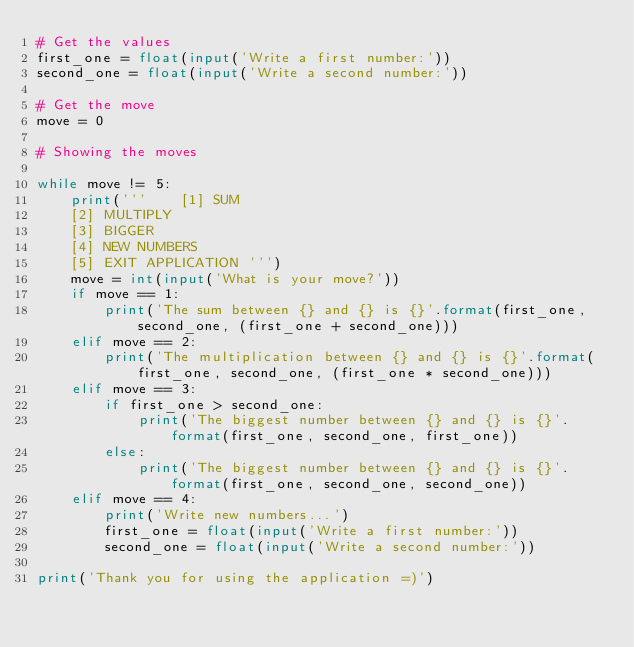Convert code to text. <code><loc_0><loc_0><loc_500><loc_500><_Python_># Get the values
first_one = float(input('Write a first number:'))
second_one = float(input('Write a second number:'))

# Get the move
move = 0

# Showing the moves

while move != 5:
    print('''    [1] SUM
    [2] MULTIPLY
    [3] BIGGER
    [4] NEW NUMBERS
    [5] EXIT APPLICATION ''')
    move = int(input('What is your move?'))
    if move == 1:
        print('The sum between {} and {} is {}'.format(first_one, second_one, (first_one + second_one)))
    elif move == 2:
        print('The multiplication between {} and {} is {}'.format(first_one, second_one, (first_one * second_one)))
    elif move == 3:
        if first_one > second_one:
            print('The biggest number between {} and {} is {}'.format(first_one, second_one, first_one))
        else:
            print('The biggest number between {} and {} is {}'.format(first_one, second_one, second_one))
    elif move == 4:
        print('Write new numbers...')
        first_one = float(input('Write a first number:'))
        second_one = float(input('Write a second number:'))

print('Thank you for using the application =)')



</code> 